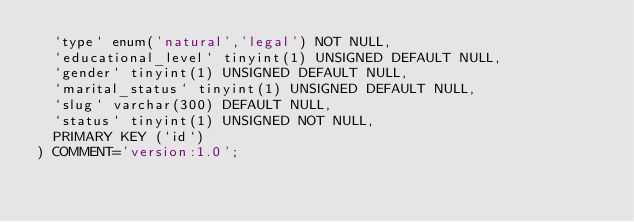<code> <loc_0><loc_0><loc_500><loc_500><_SQL_>  `type` enum('natural','legal') NOT NULL,
  `educational_level` tinyint(1) UNSIGNED DEFAULT NULL,
  `gender` tinyint(1) UNSIGNED DEFAULT NULL,
  `marital_status` tinyint(1) UNSIGNED DEFAULT NULL,
  `slug` varchar(300) DEFAULT NULL,
  `status` tinyint(1) UNSIGNED NOT NULL,
  PRIMARY KEY (`id`)
) COMMENT='version:1.0';
</code> 